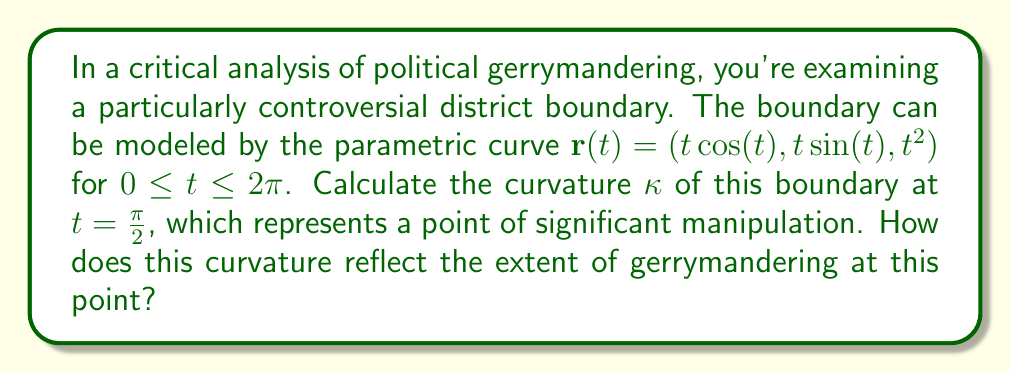Can you answer this question? To calculate the curvature of the parametric curve at $t = \frac{\pi}{2}$, we'll follow these steps:

1) The curvature formula for a parametric curve is:

   $$\kappa = \frac{|\mathbf{r}'(t) \times \mathbf{r}''(t)|}{|\mathbf{r}'(t)|^3}$$

2) First, let's calculate $\mathbf{r}'(t)$:
   $$\mathbf{r}'(t) = (\cos(t) - t\sin(t), \sin(t) + t\cos(t), 2t)$$

3) Now, let's calculate $\mathbf{r}''(t)$:
   $$\mathbf{r}''(t) = (-2\sin(t) - t\cos(t), 2\cos(t) - t\sin(t), 2)$$

4) At $t = \frac{\pi}{2}$:
   $$\mathbf{r}'(\frac{\pi}{2}) = (-\frac{\pi}{2}, 1, \pi)$$
   $$\mathbf{r}''(\frac{\pi}{2}) = (-1, -\frac{\pi}{2}, 2)$$

5) Now we need to calculate the cross product $\mathbf{r}'(\frac{\pi}{2}) \times \mathbf{r}''(\frac{\pi}{2})$:
   $$\mathbf{r}'(\frac{\pi}{2}) \times \mathbf{r}''(\frac{\pi}{2}) = \begin{vmatrix} 
   \mathbf{i} & \mathbf{j} & \mathbf{k} \\
   -\frac{\pi}{2} & 1 & \pi \\
   -1 & -\frac{\pi}{2} & 2
   \end{vmatrix} = (-\frac{\pi^2}{2}-2)\mathbf{i} + (\frac{\pi^2}{2}-\pi)\mathbf{j} + (\frac{\pi^2}{4}-1)\mathbf{k}$$

6) The magnitude of this cross product is:
   $$|\mathbf{r}'(\frac{\pi}{2}) \times \mathbf{r}''(\frac{\pi}{2})| = \sqrt{(-\frac{\pi^2}{2}-2)^2 + (\frac{\pi^2}{2}-\pi)^2 + (\frac{\pi^2}{4}-1)^2}$$

7) The magnitude of $\mathbf{r}'(\frac{\pi}{2})$ is:
   $$|\mathbf{r}'(\frac{\pi}{2})| = \sqrt{(\frac{\pi}{2})^2 + 1^2 + \pi^2} = \sqrt{\frac{5\pi^2}{4}+1}$$

8) Now we can substitute these into our curvature formula:
   $$\kappa = \frac{\sqrt{(-\frac{\pi^2}{2}-2)^2 + (\frac{\pi^2}{2}-\pi)^2 + (\frac{\pi^2}{4}-1)^2}}{(\sqrt{\frac{5\pi^2}{4}+1})^3}$$

This curvature value represents the degree of "bending" in the district boundary at this point. A higher curvature indicates a more severely manipulated boundary, potentially reflecting more extreme gerrymandering.
Answer: $$\kappa = \frac{\sqrt{(-\frac{\pi^2}{2}-2)^2 + (\frac{\pi^2}{2}-\pi)^2 + (\frac{\pi^2}{4}-1)^2}}{(\sqrt{\frac{5\pi^2}{4}+1})^3}$$ 